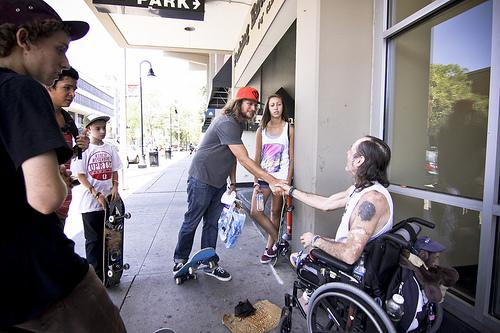Mention the setting of the image, along with a brief description of the people present. The image is taken outside during the day and features teenagers with skateboards, a man in a wheelchair smiling and shaking hands with a skateboarder, and a woman watching the scene. Describe the posture of the skateboard and one detail about a person's attire. The skateboard is tilted with its front wheels off the ground, and the man is wearing dark gray T-shirt. Write down the general setting and briefly mention a characteristic of the boy's skateboard. The picture is taken outside during the day, and the boy's skateboard is black. What is the interaction happening between a man and a boy in the picture? A man in a wheelchair is shaking hands with a skateboarder. Describe a notable aspect about the skateboard and the man wearing a cap in the scene. The skateboard is blue on the bottom, and the man is wearing a red baseball cap. Briefly describe the man in a wheelchair and one notable feature about him. The man in a wheelchair has a smiling expression and a tattoo on his shoulder. What are the two main subjects in the image and what is their point of interaction? The man in the wheelchair and the boy with a skateboard are the main subjects, and they are shaking hands. Mention the main action between the leading male characters and a distinct feature of one of them. A man and a boy are shaking hands with each other, and the man has a tattoo on his arm. What are people doing in the image, and describe their clothing. They are shaking hands with each other; the man is wearing jeans, and the boy is wearing a grey shirt and a red cap. What's a noteworthy trait of the girl present in the image, and a feature related to the setting? The girl is wearing a tank top, and a street light can be seen at the curb. 